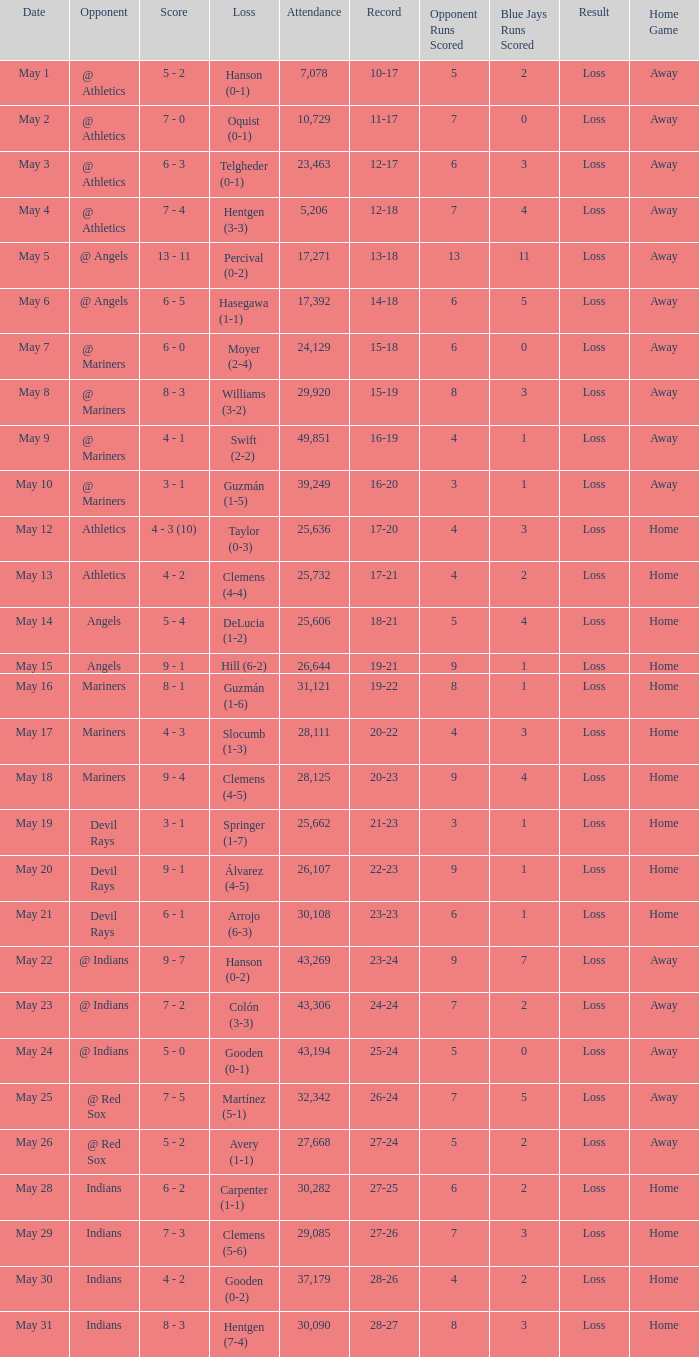What is the record for May 31? 28-27. 